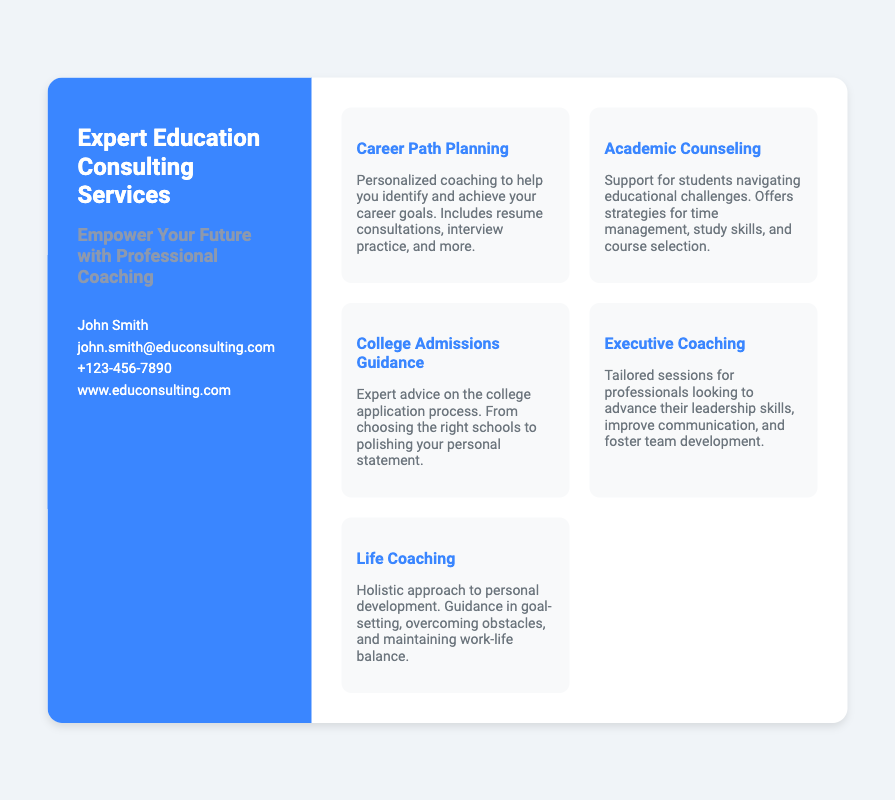What is the name of the consultant? The name of the consultant is provided in the contact section of the document.
Answer: John Smith What services are offered under coaching? The services listed include Career Path Planning, Academic Counseling, College Admissions Guidance, Executive Coaching, and Life Coaching.
Answer: Career Path Planning, Academic Counseling, College Admissions Guidance, Executive Coaching, Life Coaching What is the primary theme of the left panel? The primary theme focuses on empowerment through professional coaching, as described in the left panel.
Answer: Empower Your Future with Professional Coaching What is the contact email for inquiries? The document specifies an email address beneath the consultant's name for people to reach out.
Answer: john.smith@educonsulting.com How many services are listed in total? The total number of services provided in the document is listed, which encompasses a range of coaching options.
Answer: 5 What is the purpose of Executive Coaching? Executive Coaching aims to advance leadership skills, improve communication, and foster team development according to the description provided.
Answer: Advance leadership skills What type of support does Academic Counseling offer? Academic Counseling supports students by providing strategies related to educational challenges, as mentioned in the document.
Answer: Strategies for time management What is the website for more information? The website for additional information is presented at the bottom of the left panel in the card.
Answer: www.educonsulting.com What service focuses on personal development? The service that emphasizes personal development in the document is explicitly mentioned under Life Coaching.
Answer: Life Coaching What is included in Career Path Planning? The description for Career Path Planning states that it includes resume consultations, interview practice, and more.
Answer: Resume consultations, interview practice 